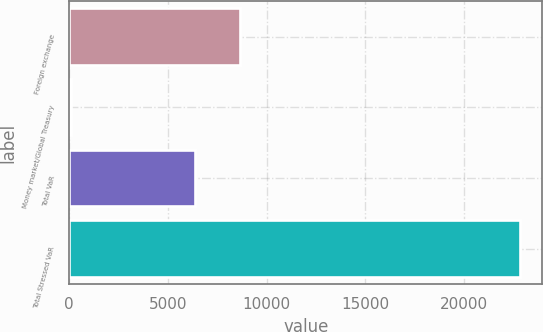<chart> <loc_0><loc_0><loc_500><loc_500><bar_chart><fcel>Foreign exchange<fcel>Money market/Global Treasury<fcel>Total VaR<fcel>Total Stressed VaR<nl><fcel>8632.8<fcel>97<fcel>6361<fcel>22815<nl></chart> 